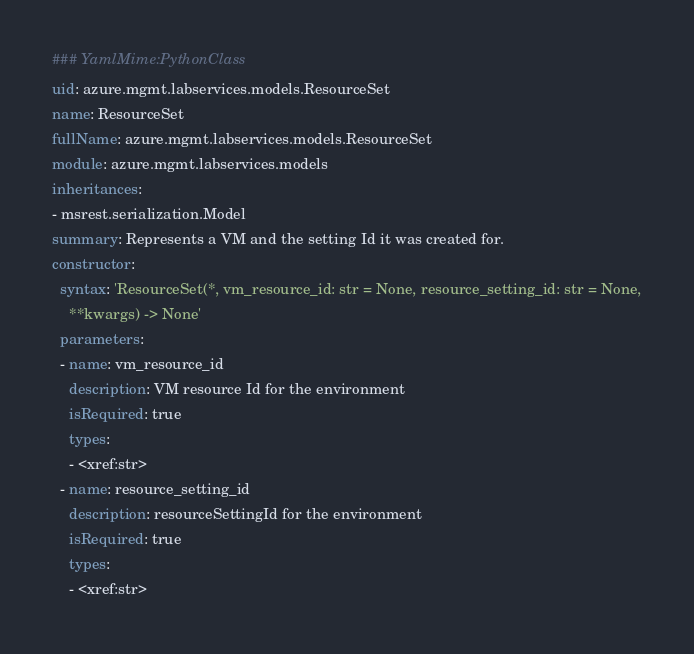Convert code to text. <code><loc_0><loc_0><loc_500><loc_500><_YAML_>### YamlMime:PythonClass
uid: azure.mgmt.labservices.models.ResourceSet
name: ResourceSet
fullName: azure.mgmt.labservices.models.ResourceSet
module: azure.mgmt.labservices.models
inheritances:
- msrest.serialization.Model
summary: Represents a VM and the setting Id it was created for.
constructor:
  syntax: 'ResourceSet(*, vm_resource_id: str = None, resource_setting_id: str = None,
    **kwargs) -> None'
  parameters:
  - name: vm_resource_id
    description: VM resource Id for the environment
    isRequired: true
    types:
    - <xref:str>
  - name: resource_setting_id
    description: resourceSettingId for the environment
    isRequired: true
    types:
    - <xref:str>
</code> 